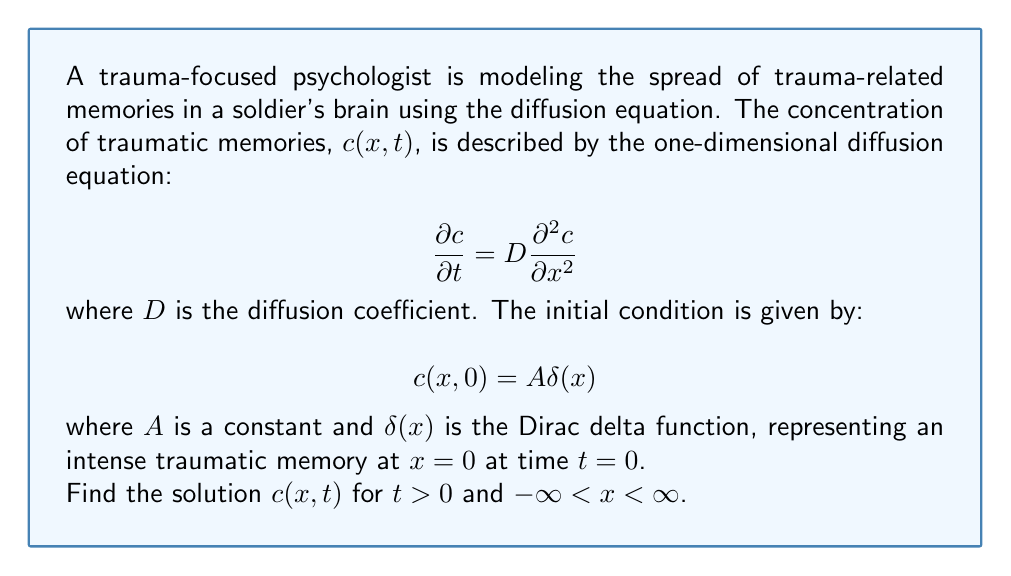Show me your answer to this math problem. To solve this problem, we'll use the Fourier transform method:

1) Take the Fourier transform of the diffusion equation with respect to x:
   $$\frac{\partial \hat{c}}{\partial t} = -Dk^2\hat{c}$$

2) Solve this ordinary differential equation:
   $$\hat{c}(k,t) = \hat{c}(k,0)e^{-Dk^2t}$$

3) The Fourier transform of the initial condition is:
   $$\hat{c}(k,0) = A$$

4) Substitute this into the solution:
   $$\hat{c}(k,t) = Ae^{-Dk^2t}$$

5) Take the inverse Fourier transform:
   $$c(x,t) = \frac{A}{2\pi}\int_{-\infty}^{\infty} e^{ikx-Dk^2t} dk$$

6) This integral can be evaluated using the Gaussian integral formula:
   $$c(x,t) = \frac{A}{\sqrt{4\pi Dt}}e^{-\frac{x^2}{4Dt}}$$

This solution represents a Gaussian distribution that spreads out over time, modeling the diffusion of traumatic memories in the brain.
Answer: $$c(x,t) = \frac{A}{\sqrt{4\pi Dt}}e^{-\frac{x^2}{4Dt}}$$ 